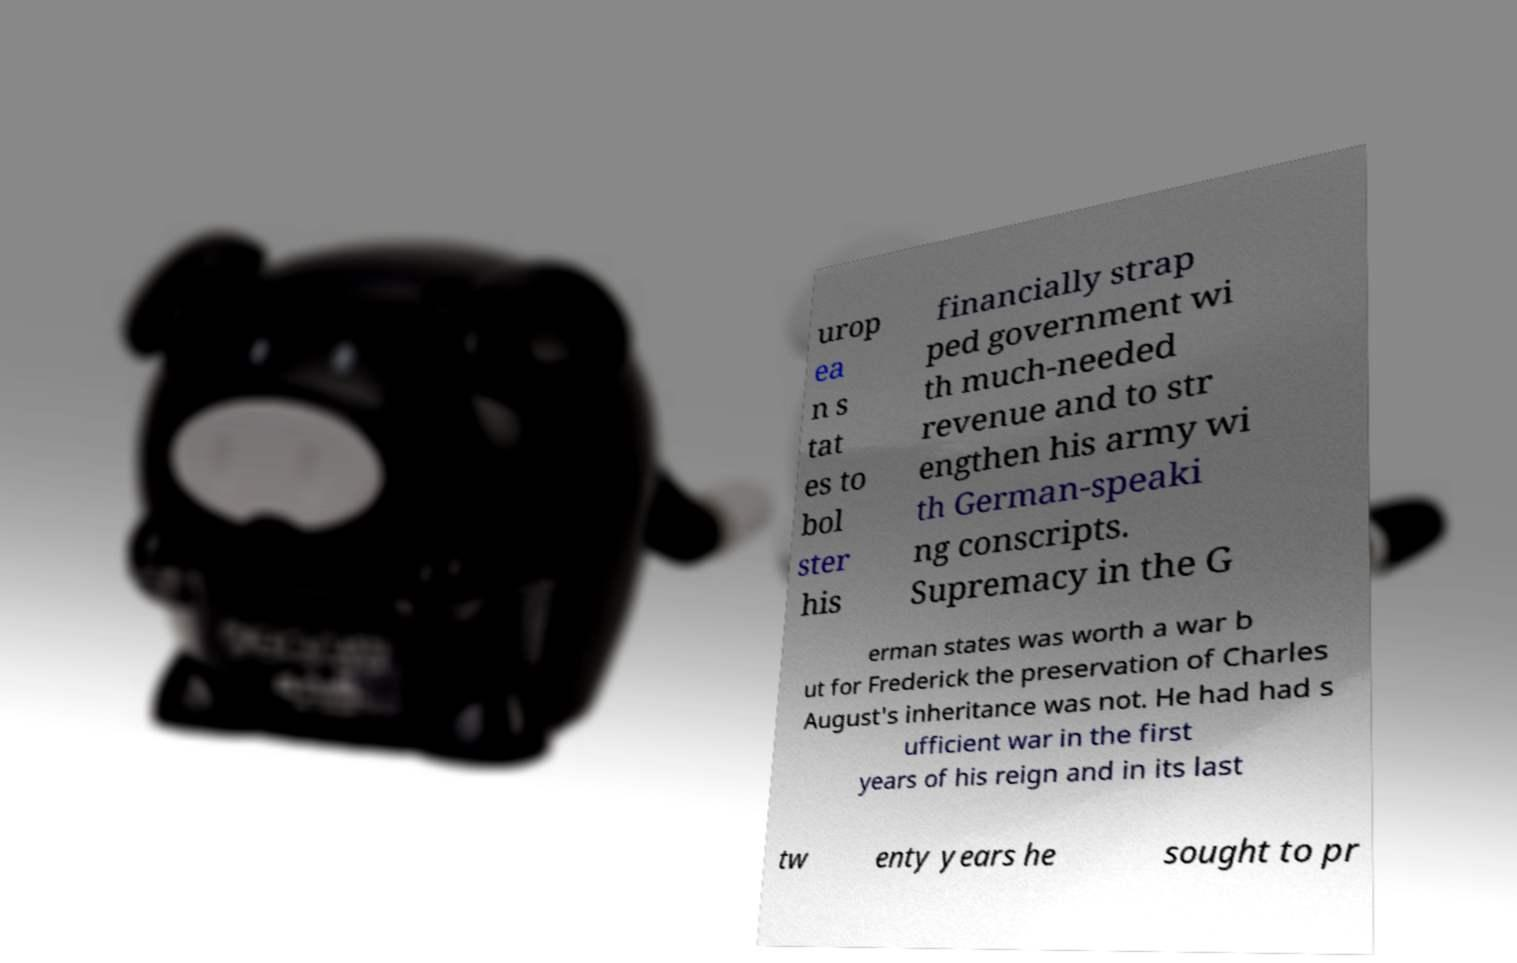Could you assist in decoding the text presented in this image and type it out clearly? urop ea n s tat es to bol ster his financially strap ped government wi th much-needed revenue and to str engthen his army wi th German-speaki ng conscripts. Supremacy in the G erman states was worth a war b ut for Frederick the preservation of Charles August's inheritance was not. He had had s ufficient war in the first years of his reign and in its last tw enty years he sought to pr 